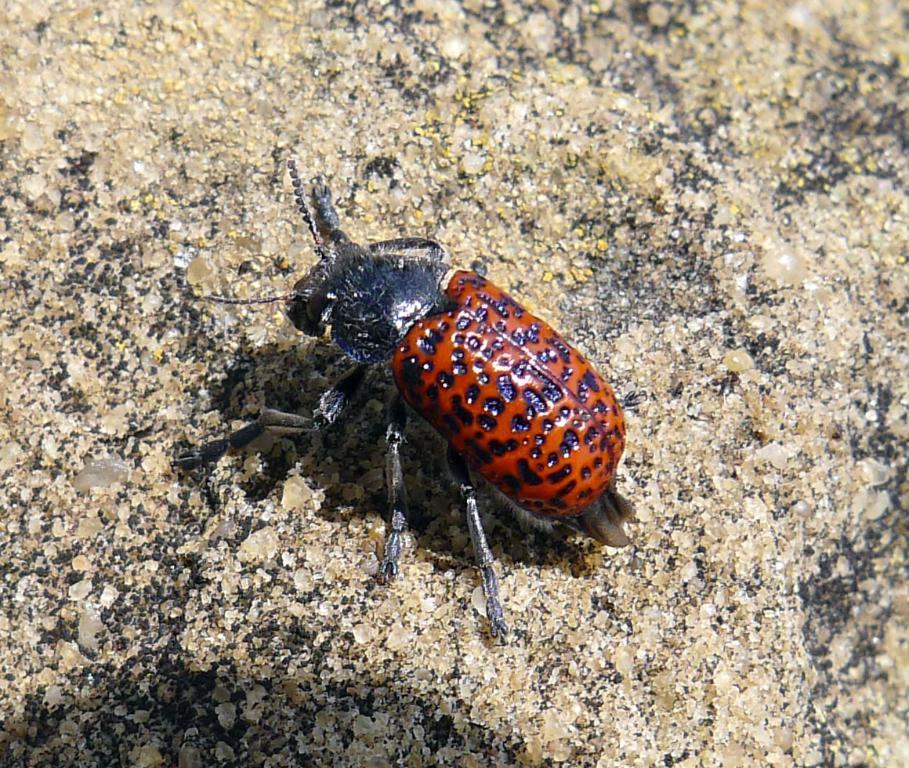In one or two sentences, can you explain what this image depicts? In the middle I can see an insect on the ground. This image is taken may be during a day. 